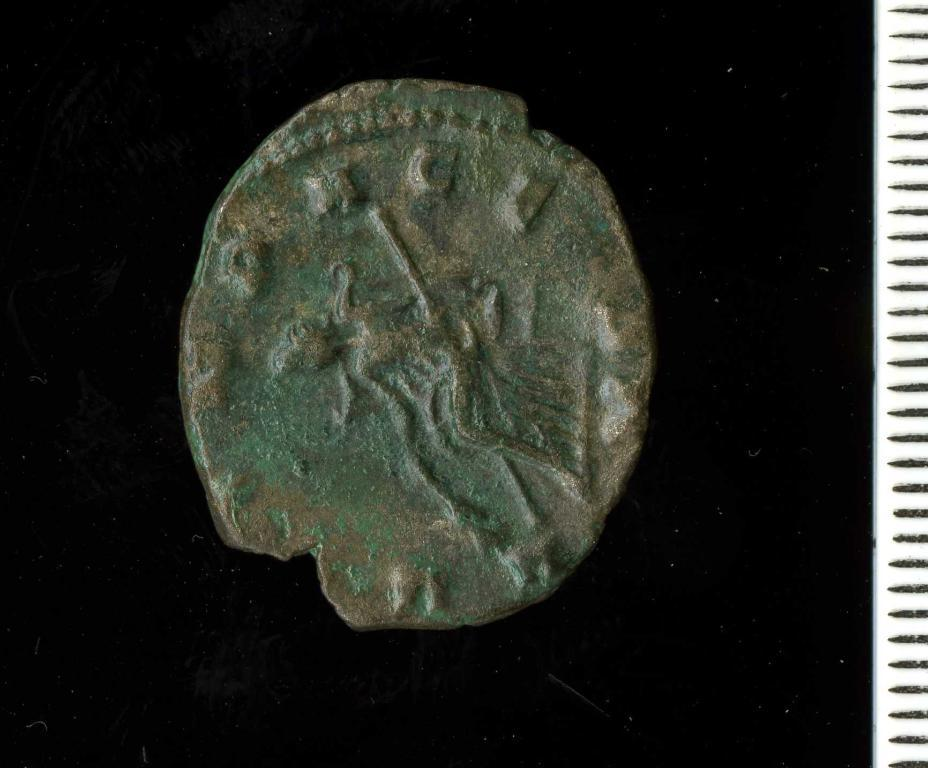What object is present in the image? There is a coin in the image. What type of feeling does the coin have in the image? The coin is an inanimate object and does not have feelings. Is there a rifle visible in the image? No, there is no rifle present in the image. What type of dinner is being served in the image? There is no dinner present in the image; it only features a coin. 